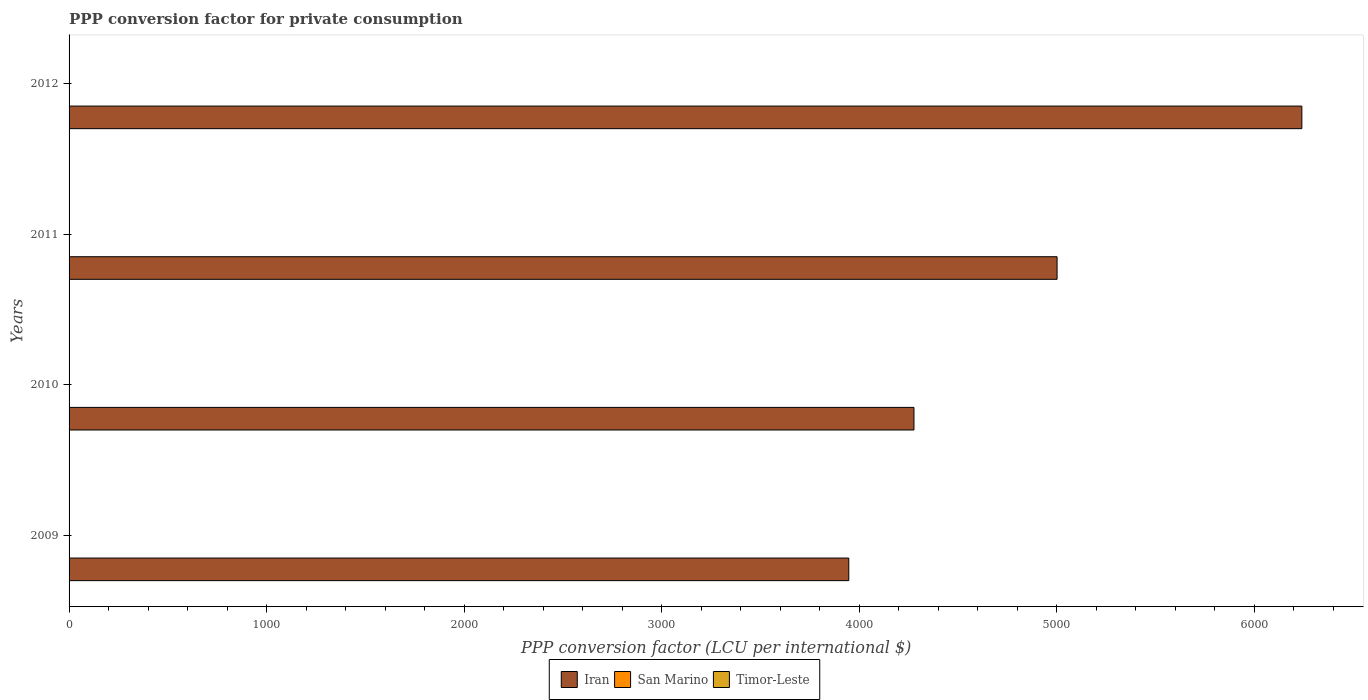How many different coloured bars are there?
Your answer should be very brief. 3. Are the number of bars per tick equal to the number of legend labels?
Provide a succinct answer. Yes. How many bars are there on the 3rd tick from the top?
Provide a succinct answer. 3. How many bars are there on the 3rd tick from the bottom?
Keep it short and to the point. 3. What is the label of the 2nd group of bars from the top?
Make the answer very short. 2011. In how many cases, is the number of bars for a given year not equal to the number of legend labels?
Keep it short and to the point. 0. What is the PPP conversion factor for private consumption in Timor-Leste in 2009?
Keep it short and to the point. 0.49. Across all years, what is the maximum PPP conversion factor for private consumption in San Marino?
Your answer should be compact. 0.78. Across all years, what is the minimum PPP conversion factor for private consumption in Iran?
Your answer should be compact. 3947.01. In which year was the PPP conversion factor for private consumption in Timor-Leste minimum?
Provide a short and direct response. 2009. What is the total PPP conversion factor for private consumption in Iran in the graph?
Offer a terse response. 1.95e+04. What is the difference between the PPP conversion factor for private consumption in Timor-Leste in 2009 and that in 2012?
Offer a very short reply. -0.13. What is the difference between the PPP conversion factor for private consumption in Timor-Leste in 2009 and the PPP conversion factor for private consumption in Iran in 2012?
Give a very brief answer. -6239.98. What is the average PPP conversion factor for private consumption in Iran per year?
Provide a succinct answer. 4866.46. In the year 2012, what is the difference between the PPP conversion factor for private consumption in Timor-Leste and PPP conversion factor for private consumption in San Marino?
Ensure brevity in your answer.  -0.16. In how many years, is the PPP conversion factor for private consumption in Timor-Leste greater than 1400 LCU?
Offer a very short reply. 0. What is the ratio of the PPP conversion factor for private consumption in Iran in 2010 to that in 2012?
Provide a succinct answer. 0.69. Is the PPP conversion factor for private consumption in San Marino in 2011 less than that in 2012?
Your answer should be compact. Yes. Is the difference between the PPP conversion factor for private consumption in Timor-Leste in 2010 and 2011 greater than the difference between the PPP conversion factor for private consumption in San Marino in 2010 and 2011?
Ensure brevity in your answer.  No. What is the difference between the highest and the second highest PPP conversion factor for private consumption in Iran?
Give a very brief answer. 1239.11. What is the difference between the highest and the lowest PPP conversion factor for private consumption in Timor-Leste?
Offer a terse response. 0.13. Is the sum of the PPP conversion factor for private consumption in San Marino in 2010 and 2011 greater than the maximum PPP conversion factor for private consumption in Iran across all years?
Give a very brief answer. No. What does the 3rd bar from the top in 2009 represents?
Provide a succinct answer. Iran. What does the 1st bar from the bottom in 2012 represents?
Give a very brief answer. Iran. Is it the case that in every year, the sum of the PPP conversion factor for private consumption in Timor-Leste and PPP conversion factor for private consumption in San Marino is greater than the PPP conversion factor for private consumption in Iran?
Your answer should be very brief. No. How many bars are there?
Your answer should be compact. 12. Are all the bars in the graph horizontal?
Your answer should be compact. Yes. How many legend labels are there?
Your answer should be very brief. 3. What is the title of the graph?
Your answer should be compact. PPP conversion factor for private consumption. What is the label or title of the X-axis?
Your response must be concise. PPP conversion factor (LCU per international $). What is the PPP conversion factor (LCU per international $) of Iran in 2009?
Offer a terse response. 3947.01. What is the PPP conversion factor (LCU per international $) in San Marino in 2009?
Provide a succinct answer. 0.77. What is the PPP conversion factor (LCU per international $) of Timor-Leste in 2009?
Keep it short and to the point. 0.49. What is the PPP conversion factor (LCU per international $) of Iran in 2010?
Keep it short and to the point. 4276.98. What is the PPP conversion factor (LCU per international $) of San Marino in 2010?
Provide a succinct answer. 0.78. What is the PPP conversion factor (LCU per international $) of Timor-Leste in 2010?
Offer a terse response. 0.51. What is the PPP conversion factor (LCU per international $) of Iran in 2011?
Offer a terse response. 5001.36. What is the PPP conversion factor (LCU per international $) of San Marino in 2011?
Provide a short and direct response. 0.77. What is the PPP conversion factor (LCU per international $) of Timor-Leste in 2011?
Your answer should be compact. 0.56. What is the PPP conversion factor (LCU per international $) in Iran in 2012?
Offer a very short reply. 6240.47. What is the PPP conversion factor (LCU per international $) in San Marino in 2012?
Keep it short and to the point. 0.78. What is the PPP conversion factor (LCU per international $) of Timor-Leste in 2012?
Your response must be concise. 0.61. Across all years, what is the maximum PPP conversion factor (LCU per international $) in Iran?
Your answer should be compact. 6240.47. Across all years, what is the maximum PPP conversion factor (LCU per international $) in San Marino?
Ensure brevity in your answer.  0.78. Across all years, what is the maximum PPP conversion factor (LCU per international $) in Timor-Leste?
Keep it short and to the point. 0.61. Across all years, what is the minimum PPP conversion factor (LCU per international $) in Iran?
Make the answer very short. 3947.01. Across all years, what is the minimum PPP conversion factor (LCU per international $) in San Marino?
Ensure brevity in your answer.  0.77. Across all years, what is the minimum PPP conversion factor (LCU per international $) in Timor-Leste?
Offer a terse response. 0.49. What is the total PPP conversion factor (LCU per international $) of Iran in the graph?
Keep it short and to the point. 1.95e+04. What is the total PPP conversion factor (LCU per international $) of San Marino in the graph?
Your answer should be very brief. 3.11. What is the total PPP conversion factor (LCU per international $) of Timor-Leste in the graph?
Ensure brevity in your answer.  2.17. What is the difference between the PPP conversion factor (LCU per international $) in Iran in 2009 and that in 2010?
Make the answer very short. -329.97. What is the difference between the PPP conversion factor (LCU per international $) in San Marino in 2009 and that in 2010?
Offer a terse response. -0.01. What is the difference between the PPP conversion factor (LCU per international $) in Timor-Leste in 2009 and that in 2010?
Provide a short and direct response. -0.02. What is the difference between the PPP conversion factor (LCU per international $) in Iran in 2009 and that in 2011?
Ensure brevity in your answer.  -1054.35. What is the difference between the PPP conversion factor (LCU per international $) in San Marino in 2009 and that in 2011?
Offer a very short reply. 0. What is the difference between the PPP conversion factor (LCU per international $) of Timor-Leste in 2009 and that in 2011?
Offer a terse response. -0.08. What is the difference between the PPP conversion factor (LCU per international $) of Iran in 2009 and that in 2012?
Offer a terse response. -2293.46. What is the difference between the PPP conversion factor (LCU per international $) in San Marino in 2009 and that in 2012?
Your response must be concise. -0. What is the difference between the PPP conversion factor (LCU per international $) in Timor-Leste in 2009 and that in 2012?
Offer a very short reply. -0.13. What is the difference between the PPP conversion factor (LCU per international $) in Iran in 2010 and that in 2011?
Ensure brevity in your answer.  -724.38. What is the difference between the PPP conversion factor (LCU per international $) in San Marino in 2010 and that in 2011?
Your answer should be very brief. 0.01. What is the difference between the PPP conversion factor (LCU per international $) of Timor-Leste in 2010 and that in 2011?
Provide a succinct answer. -0.05. What is the difference between the PPP conversion factor (LCU per international $) of Iran in 2010 and that in 2012?
Provide a succinct answer. -1963.49. What is the difference between the PPP conversion factor (LCU per international $) in San Marino in 2010 and that in 2012?
Ensure brevity in your answer.  0. What is the difference between the PPP conversion factor (LCU per international $) of Timor-Leste in 2010 and that in 2012?
Your answer should be compact. -0.1. What is the difference between the PPP conversion factor (LCU per international $) in Iran in 2011 and that in 2012?
Make the answer very short. -1239.11. What is the difference between the PPP conversion factor (LCU per international $) in San Marino in 2011 and that in 2012?
Provide a succinct answer. -0.01. What is the difference between the PPP conversion factor (LCU per international $) in Timor-Leste in 2011 and that in 2012?
Keep it short and to the point. -0.05. What is the difference between the PPP conversion factor (LCU per international $) of Iran in 2009 and the PPP conversion factor (LCU per international $) of San Marino in 2010?
Provide a succinct answer. 3946.23. What is the difference between the PPP conversion factor (LCU per international $) of Iran in 2009 and the PPP conversion factor (LCU per international $) of Timor-Leste in 2010?
Your answer should be compact. 3946.5. What is the difference between the PPP conversion factor (LCU per international $) in San Marino in 2009 and the PPP conversion factor (LCU per international $) in Timor-Leste in 2010?
Offer a terse response. 0.26. What is the difference between the PPP conversion factor (LCU per international $) in Iran in 2009 and the PPP conversion factor (LCU per international $) in San Marino in 2011?
Keep it short and to the point. 3946.24. What is the difference between the PPP conversion factor (LCU per international $) in Iran in 2009 and the PPP conversion factor (LCU per international $) in Timor-Leste in 2011?
Provide a short and direct response. 3946.45. What is the difference between the PPP conversion factor (LCU per international $) of San Marino in 2009 and the PPP conversion factor (LCU per international $) of Timor-Leste in 2011?
Ensure brevity in your answer.  0.21. What is the difference between the PPP conversion factor (LCU per international $) of Iran in 2009 and the PPP conversion factor (LCU per international $) of San Marino in 2012?
Provide a succinct answer. 3946.23. What is the difference between the PPP conversion factor (LCU per international $) in Iran in 2009 and the PPP conversion factor (LCU per international $) in Timor-Leste in 2012?
Provide a succinct answer. 3946.39. What is the difference between the PPP conversion factor (LCU per international $) of San Marino in 2009 and the PPP conversion factor (LCU per international $) of Timor-Leste in 2012?
Give a very brief answer. 0.16. What is the difference between the PPP conversion factor (LCU per international $) in Iran in 2010 and the PPP conversion factor (LCU per international $) in San Marino in 2011?
Offer a very short reply. 4276.21. What is the difference between the PPP conversion factor (LCU per international $) of Iran in 2010 and the PPP conversion factor (LCU per international $) of Timor-Leste in 2011?
Your response must be concise. 4276.42. What is the difference between the PPP conversion factor (LCU per international $) in San Marino in 2010 and the PPP conversion factor (LCU per international $) in Timor-Leste in 2011?
Provide a short and direct response. 0.22. What is the difference between the PPP conversion factor (LCU per international $) in Iran in 2010 and the PPP conversion factor (LCU per international $) in San Marino in 2012?
Ensure brevity in your answer.  4276.2. What is the difference between the PPP conversion factor (LCU per international $) in Iran in 2010 and the PPP conversion factor (LCU per international $) in Timor-Leste in 2012?
Your answer should be compact. 4276.36. What is the difference between the PPP conversion factor (LCU per international $) in San Marino in 2010 and the PPP conversion factor (LCU per international $) in Timor-Leste in 2012?
Offer a very short reply. 0.17. What is the difference between the PPP conversion factor (LCU per international $) of Iran in 2011 and the PPP conversion factor (LCU per international $) of San Marino in 2012?
Keep it short and to the point. 5000.58. What is the difference between the PPP conversion factor (LCU per international $) of Iran in 2011 and the PPP conversion factor (LCU per international $) of Timor-Leste in 2012?
Offer a very short reply. 5000.75. What is the difference between the PPP conversion factor (LCU per international $) in San Marino in 2011 and the PPP conversion factor (LCU per international $) in Timor-Leste in 2012?
Your answer should be compact. 0.16. What is the average PPP conversion factor (LCU per international $) of Iran per year?
Keep it short and to the point. 4866.46. What is the average PPP conversion factor (LCU per international $) in San Marino per year?
Keep it short and to the point. 0.78. What is the average PPP conversion factor (LCU per international $) in Timor-Leste per year?
Provide a short and direct response. 0.54. In the year 2009, what is the difference between the PPP conversion factor (LCU per international $) of Iran and PPP conversion factor (LCU per international $) of San Marino?
Your answer should be compact. 3946.23. In the year 2009, what is the difference between the PPP conversion factor (LCU per international $) in Iran and PPP conversion factor (LCU per international $) in Timor-Leste?
Your response must be concise. 3946.52. In the year 2009, what is the difference between the PPP conversion factor (LCU per international $) in San Marino and PPP conversion factor (LCU per international $) in Timor-Leste?
Offer a very short reply. 0.29. In the year 2010, what is the difference between the PPP conversion factor (LCU per international $) in Iran and PPP conversion factor (LCU per international $) in San Marino?
Keep it short and to the point. 4276.2. In the year 2010, what is the difference between the PPP conversion factor (LCU per international $) of Iran and PPP conversion factor (LCU per international $) of Timor-Leste?
Give a very brief answer. 4276.47. In the year 2010, what is the difference between the PPP conversion factor (LCU per international $) in San Marino and PPP conversion factor (LCU per international $) in Timor-Leste?
Offer a terse response. 0.27. In the year 2011, what is the difference between the PPP conversion factor (LCU per international $) of Iran and PPP conversion factor (LCU per international $) of San Marino?
Your answer should be compact. 5000.59. In the year 2011, what is the difference between the PPP conversion factor (LCU per international $) in Iran and PPP conversion factor (LCU per international $) in Timor-Leste?
Your answer should be compact. 5000.8. In the year 2011, what is the difference between the PPP conversion factor (LCU per international $) in San Marino and PPP conversion factor (LCU per international $) in Timor-Leste?
Make the answer very short. 0.21. In the year 2012, what is the difference between the PPP conversion factor (LCU per international $) of Iran and PPP conversion factor (LCU per international $) of San Marino?
Your answer should be very brief. 6239.69. In the year 2012, what is the difference between the PPP conversion factor (LCU per international $) in Iran and PPP conversion factor (LCU per international $) in Timor-Leste?
Give a very brief answer. 6239.85. In the year 2012, what is the difference between the PPP conversion factor (LCU per international $) of San Marino and PPP conversion factor (LCU per international $) of Timor-Leste?
Provide a short and direct response. 0.16. What is the ratio of the PPP conversion factor (LCU per international $) of Iran in 2009 to that in 2010?
Your response must be concise. 0.92. What is the ratio of the PPP conversion factor (LCU per international $) in Timor-Leste in 2009 to that in 2010?
Ensure brevity in your answer.  0.95. What is the ratio of the PPP conversion factor (LCU per international $) in Iran in 2009 to that in 2011?
Make the answer very short. 0.79. What is the ratio of the PPP conversion factor (LCU per international $) in Timor-Leste in 2009 to that in 2011?
Your answer should be very brief. 0.87. What is the ratio of the PPP conversion factor (LCU per international $) in Iran in 2009 to that in 2012?
Your answer should be very brief. 0.63. What is the ratio of the PPP conversion factor (LCU per international $) in Timor-Leste in 2009 to that in 2012?
Provide a short and direct response. 0.79. What is the ratio of the PPP conversion factor (LCU per international $) of Iran in 2010 to that in 2011?
Your answer should be compact. 0.86. What is the ratio of the PPP conversion factor (LCU per international $) of San Marino in 2010 to that in 2011?
Your answer should be very brief. 1.01. What is the ratio of the PPP conversion factor (LCU per international $) of Timor-Leste in 2010 to that in 2011?
Provide a short and direct response. 0.91. What is the ratio of the PPP conversion factor (LCU per international $) of Iran in 2010 to that in 2012?
Make the answer very short. 0.69. What is the ratio of the PPP conversion factor (LCU per international $) of Timor-Leste in 2010 to that in 2012?
Give a very brief answer. 0.83. What is the ratio of the PPP conversion factor (LCU per international $) in Iran in 2011 to that in 2012?
Your response must be concise. 0.8. What is the ratio of the PPP conversion factor (LCU per international $) in Timor-Leste in 2011 to that in 2012?
Provide a succinct answer. 0.91. What is the difference between the highest and the second highest PPP conversion factor (LCU per international $) in Iran?
Make the answer very short. 1239.11. What is the difference between the highest and the second highest PPP conversion factor (LCU per international $) in San Marino?
Give a very brief answer. 0. What is the difference between the highest and the second highest PPP conversion factor (LCU per international $) of Timor-Leste?
Your answer should be very brief. 0.05. What is the difference between the highest and the lowest PPP conversion factor (LCU per international $) in Iran?
Offer a terse response. 2293.46. What is the difference between the highest and the lowest PPP conversion factor (LCU per international $) in San Marino?
Keep it short and to the point. 0.01. What is the difference between the highest and the lowest PPP conversion factor (LCU per international $) of Timor-Leste?
Provide a short and direct response. 0.13. 